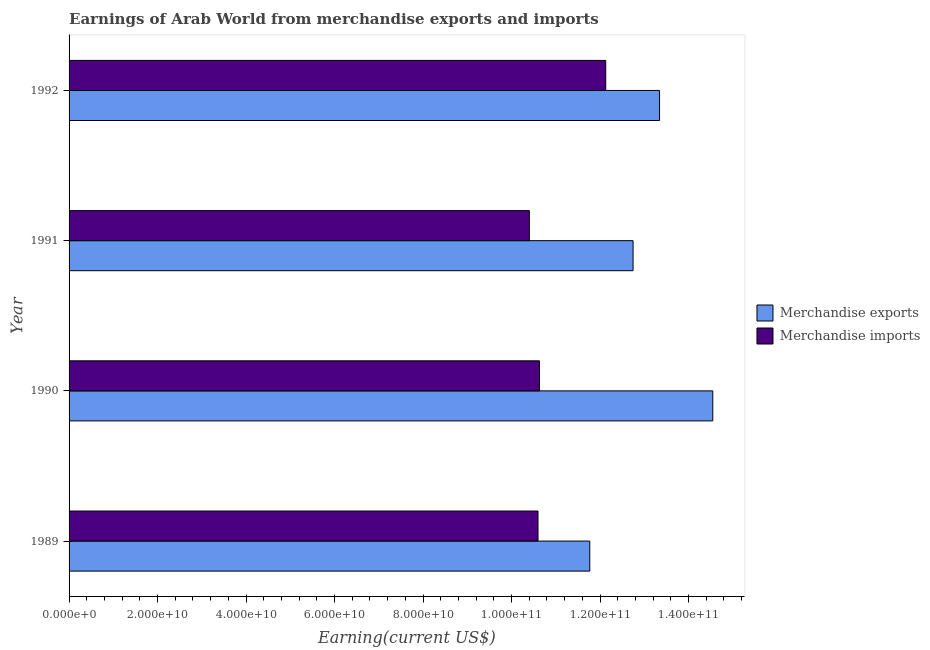Are the number of bars per tick equal to the number of legend labels?
Your response must be concise. Yes. What is the label of the 2nd group of bars from the top?
Provide a short and direct response. 1991. What is the earnings from merchandise exports in 1991?
Offer a terse response. 1.27e+11. Across all years, what is the maximum earnings from merchandise imports?
Provide a succinct answer. 1.21e+11. Across all years, what is the minimum earnings from merchandise imports?
Your answer should be very brief. 1.04e+11. In which year was the earnings from merchandise exports maximum?
Your response must be concise. 1990. What is the total earnings from merchandise exports in the graph?
Offer a terse response. 5.24e+11. What is the difference between the earnings from merchandise imports in 1991 and that in 1992?
Give a very brief answer. -1.73e+1. What is the difference between the earnings from merchandise exports in 1992 and the earnings from merchandise imports in 1989?
Provide a succinct answer. 2.75e+1. What is the average earnings from merchandise exports per year?
Offer a terse response. 1.31e+11. In the year 1990, what is the difference between the earnings from merchandise exports and earnings from merchandise imports?
Your answer should be very brief. 3.92e+1. What is the ratio of the earnings from merchandise exports in 1990 to that in 1992?
Offer a very short reply. 1.09. What is the difference between the highest and the second highest earnings from merchandise imports?
Ensure brevity in your answer.  1.50e+1. What is the difference between the highest and the lowest earnings from merchandise imports?
Offer a terse response. 1.73e+1. In how many years, is the earnings from merchandise imports greater than the average earnings from merchandise imports taken over all years?
Your answer should be compact. 1. What does the 2nd bar from the top in 1992 represents?
Make the answer very short. Merchandise exports. What does the 2nd bar from the bottom in 1991 represents?
Provide a short and direct response. Merchandise imports. Are all the bars in the graph horizontal?
Give a very brief answer. Yes. What is the difference between two consecutive major ticks on the X-axis?
Your response must be concise. 2.00e+1. Are the values on the major ticks of X-axis written in scientific E-notation?
Provide a short and direct response. Yes. Where does the legend appear in the graph?
Provide a short and direct response. Center right. How many legend labels are there?
Offer a terse response. 2. What is the title of the graph?
Make the answer very short. Earnings of Arab World from merchandise exports and imports. What is the label or title of the X-axis?
Your answer should be compact. Earning(current US$). What is the label or title of the Y-axis?
Give a very brief answer. Year. What is the Earning(current US$) in Merchandise exports in 1989?
Offer a terse response. 1.18e+11. What is the Earning(current US$) in Merchandise imports in 1989?
Your answer should be very brief. 1.06e+11. What is the Earning(current US$) in Merchandise exports in 1990?
Keep it short and to the point. 1.45e+11. What is the Earning(current US$) of Merchandise imports in 1990?
Ensure brevity in your answer.  1.06e+11. What is the Earning(current US$) of Merchandise exports in 1991?
Offer a very short reply. 1.27e+11. What is the Earning(current US$) in Merchandise imports in 1991?
Make the answer very short. 1.04e+11. What is the Earning(current US$) in Merchandise exports in 1992?
Keep it short and to the point. 1.33e+11. What is the Earning(current US$) in Merchandise imports in 1992?
Make the answer very short. 1.21e+11. Across all years, what is the maximum Earning(current US$) in Merchandise exports?
Provide a short and direct response. 1.45e+11. Across all years, what is the maximum Earning(current US$) in Merchandise imports?
Your answer should be very brief. 1.21e+11. Across all years, what is the minimum Earning(current US$) in Merchandise exports?
Keep it short and to the point. 1.18e+11. Across all years, what is the minimum Earning(current US$) of Merchandise imports?
Make the answer very short. 1.04e+11. What is the total Earning(current US$) in Merchandise exports in the graph?
Your answer should be compact. 5.24e+11. What is the total Earning(current US$) of Merchandise imports in the graph?
Provide a succinct answer. 4.38e+11. What is the difference between the Earning(current US$) of Merchandise exports in 1989 and that in 1990?
Keep it short and to the point. -2.78e+1. What is the difference between the Earning(current US$) of Merchandise imports in 1989 and that in 1990?
Ensure brevity in your answer.  -3.35e+08. What is the difference between the Earning(current US$) of Merchandise exports in 1989 and that in 1991?
Your response must be concise. -9.78e+09. What is the difference between the Earning(current US$) of Merchandise imports in 1989 and that in 1991?
Your answer should be very brief. 1.96e+09. What is the difference between the Earning(current US$) of Merchandise exports in 1989 and that in 1992?
Make the answer very short. -1.58e+1. What is the difference between the Earning(current US$) in Merchandise imports in 1989 and that in 1992?
Your answer should be compact. -1.53e+1. What is the difference between the Earning(current US$) of Merchandise exports in 1990 and that in 1991?
Your answer should be very brief. 1.80e+1. What is the difference between the Earning(current US$) of Merchandise imports in 1990 and that in 1991?
Keep it short and to the point. 2.29e+09. What is the difference between the Earning(current US$) in Merchandise exports in 1990 and that in 1992?
Provide a succinct answer. 1.20e+1. What is the difference between the Earning(current US$) of Merchandise imports in 1990 and that in 1992?
Provide a succinct answer. -1.50e+1. What is the difference between the Earning(current US$) of Merchandise exports in 1991 and that in 1992?
Your answer should be compact. -5.98e+09. What is the difference between the Earning(current US$) of Merchandise imports in 1991 and that in 1992?
Provide a succinct answer. -1.73e+1. What is the difference between the Earning(current US$) in Merchandise exports in 1989 and the Earning(current US$) in Merchandise imports in 1990?
Provide a short and direct response. 1.14e+1. What is the difference between the Earning(current US$) in Merchandise exports in 1989 and the Earning(current US$) in Merchandise imports in 1991?
Your response must be concise. 1.37e+1. What is the difference between the Earning(current US$) in Merchandise exports in 1989 and the Earning(current US$) in Merchandise imports in 1992?
Keep it short and to the point. -3.60e+09. What is the difference between the Earning(current US$) of Merchandise exports in 1990 and the Earning(current US$) of Merchandise imports in 1991?
Give a very brief answer. 4.15e+1. What is the difference between the Earning(current US$) of Merchandise exports in 1990 and the Earning(current US$) of Merchandise imports in 1992?
Offer a very short reply. 2.42e+1. What is the difference between the Earning(current US$) of Merchandise exports in 1991 and the Earning(current US$) of Merchandise imports in 1992?
Your response must be concise. 6.18e+09. What is the average Earning(current US$) of Merchandise exports per year?
Your answer should be compact. 1.31e+11. What is the average Earning(current US$) of Merchandise imports per year?
Keep it short and to the point. 1.09e+11. In the year 1989, what is the difference between the Earning(current US$) of Merchandise exports and Earning(current US$) of Merchandise imports?
Provide a succinct answer. 1.17e+1. In the year 1990, what is the difference between the Earning(current US$) of Merchandise exports and Earning(current US$) of Merchandise imports?
Offer a very short reply. 3.92e+1. In the year 1991, what is the difference between the Earning(current US$) in Merchandise exports and Earning(current US$) in Merchandise imports?
Provide a short and direct response. 2.34e+1. In the year 1992, what is the difference between the Earning(current US$) in Merchandise exports and Earning(current US$) in Merchandise imports?
Make the answer very short. 1.22e+1. What is the ratio of the Earning(current US$) in Merchandise exports in 1989 to that in 1990?
Keep it short and to the point. 0.81. What is the ratio of the Earning(current US$) in Merchandise imports in 1989 to that in 1990?
Your answer should be compact. 1. What is the ratio of the Earning(current US$) in Merchandise exports in 1989 to that in 1991?
Give a very brief answer. 0.92. What is the ratio of the Earning(current US$) in Merchandise imports in 1989 to that in 1991?
Offer a terse response. 1.02. What is the ratio of the Earning(current US$) in Merchandise exports in 1989 to that in 1992?
Your response must be concise. 0.88. What is the ratio of the Earning(current US$) in Merchandise imports in 1989 to that in 1992?
Keep it short and to the point. 0.87. What is the ratio of the Earning(current US$) of Merchandise exports in 1990 to that in 1991?
Offer a terse response. 1.14. What is the ratio of the Earning(current US$) in Merchandise exports in 1990 to that in 1992?
Your answer should be very brief. 1.09. What is the ratio of the Earning(current US$) of Merchandise imports in 1990 to that in 1992?
Your answer should be compact. 0.88. What is the ratio of the Earning(current US$) of Merchandise exports in 1991 to that in 1992?
Provide a short and direct response. 0.96. What is the ratio of the Earning(current US$) of Merchandise imports in 1991 to that in 1992?
Make the answer very short. 0.86. What is the difference between the highest and the second highest Earning(current US$) of Merchandise exports?
Give a very brief answer. 1.20e+1. What is the difference between the highest and the second highest Earning(current US$) of Merchandise imports?
Provide a succinct answer. 1.50e+1. What is the difference between the highest and the lowest Earning(current US$) of Merchandise exports?
Offer a terse response. 2.78e+1. What is the difference between the highest and the lowest Earning(current US$) in Merchandise imports?
Ensure brevity in your answer.  1.73e+1. 